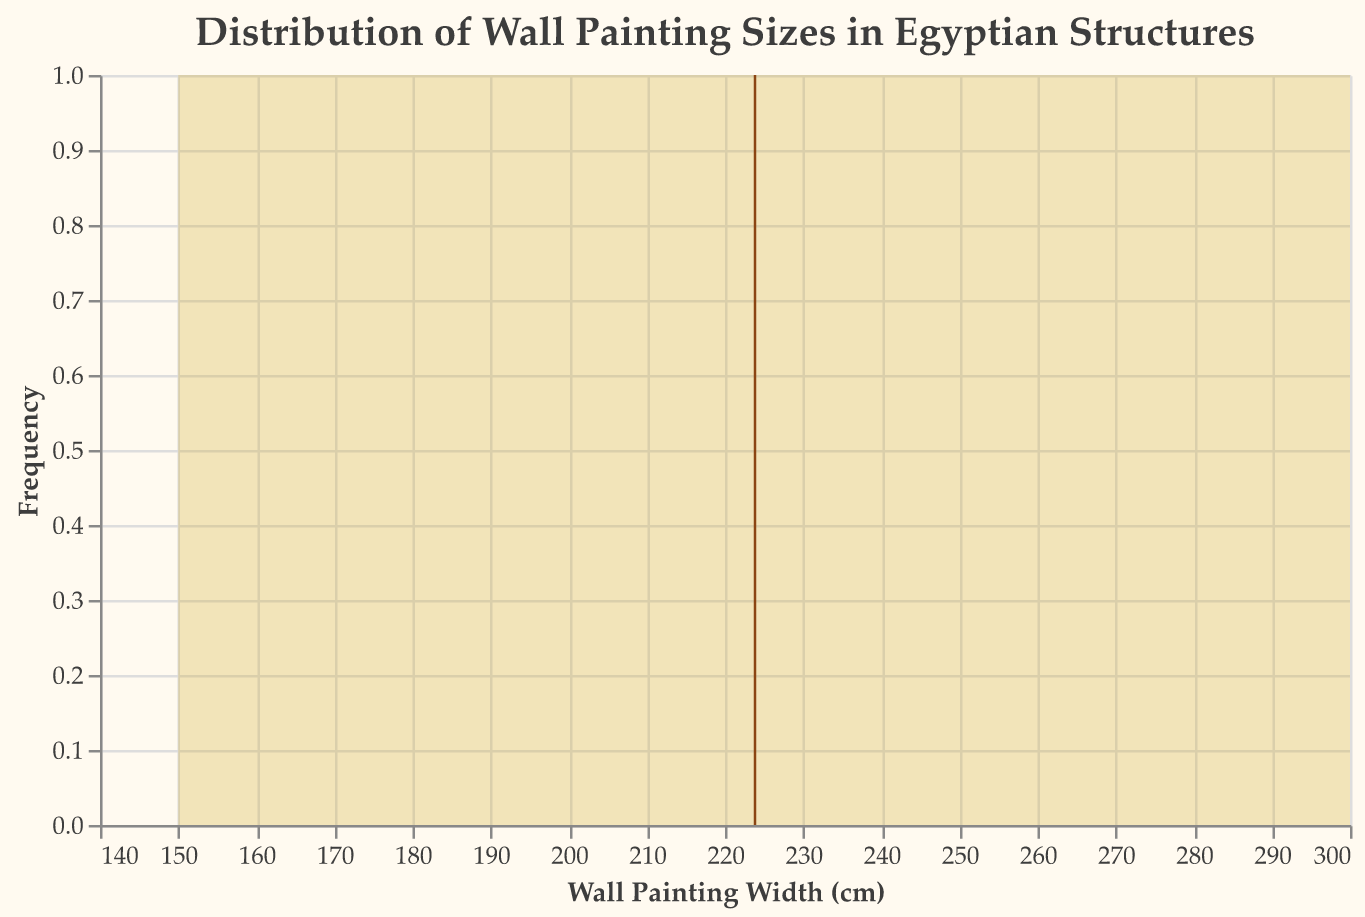What's the title of the figure? The title is usually located at the top of the figure. In this case, it states, "Distribution of Wall Painting Sizes in Egyptian Structures."
Answer: Distribution of Wall Painting Sizes in Egyptian Structures What does the x-axis represent? The x-axis label is present at the bottom of the axis and reads "Wall Painting Width (cm)."
Answer: Wall Painting Width (cm) What is shown by the y-axis? The y-axis label, located vertically on the left side, reads "Frequency," indicating the count of wall paintings for each width range.
Answer: Frequency Which period appears to have the largest wall paintings on display according to the figure? Based on the data, and by observing the x-axis range where the larger sizes are clustered (250-300 cm), one can conclude these sizes were mostly from the New Kingdom.
Answer: New Kingdom How can you identify the mean wall painting width in the figure? The mean width is indicated by a vertical rule (line) in the figure, which provides a visual marker where it intersects the x-axis.
Answer: Vertical rule What's the approximate mean wall painting width? The vertical rule crosses the x-axis around the value of 220 cm, indicating the mean width.
Answer: 220 cm Which range of wall painting widths appears to have the highest frequency? By examining the height of the area plot along the x-axis, the range around 250 cm appears to have the highest peak and thus the highest frequency.
Answer: Around 250 cm Are there more wall paintings wider than 250 cm or narrower than 150 cm? By looking at the area covered by the plot to the right of 250 cm compared to the left of 150 cm, there are more paintings wider than 250 cm as the area is more substantial there.
Answer: Wider than 250 cm What periods are represented in the figure? The figure includes data from the Old Kingdom, New Kingdom, and Ptolemaic Period.
Answer: Old Kingdom, New Kingdom, Ptolemaic Period Based on the figure, what could be inferred about the evolution of wall painting sizes over different periods? Considering the clustering of larger widths in the New Kingdom, it suggests an evolution towards larger wall paintings in that period compared to the Old Kingdom. The trend continues during the Ptolemaic Period but at a slightly smaller scale than the New Kingdom.
Answer: Evolution towards larger wall paintings in the New Kingdom and a slight reduction in the Ptolemaic Period 